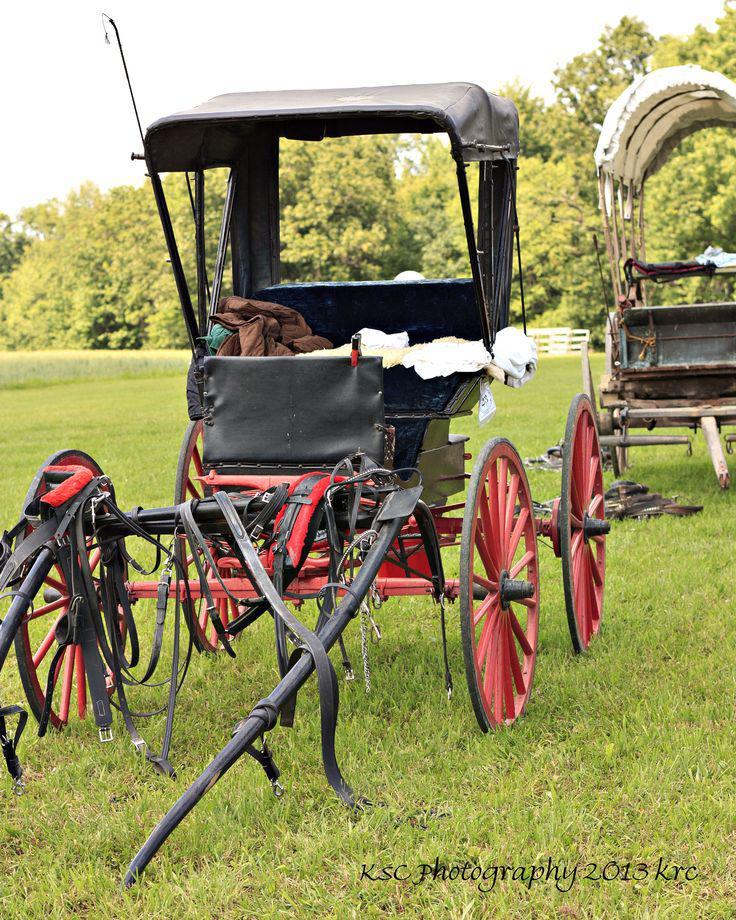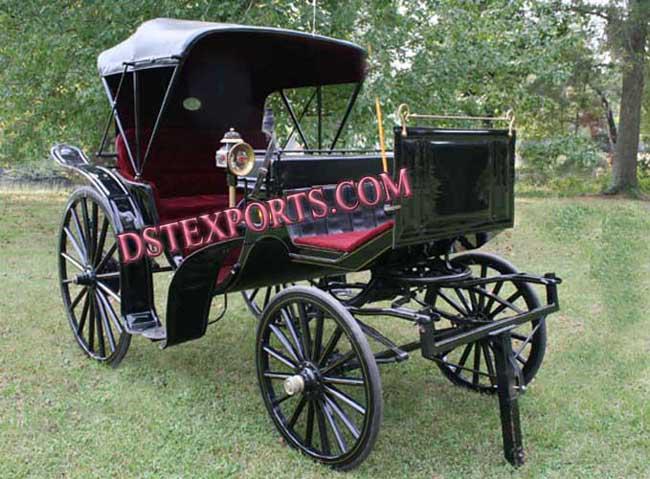The first image is the image on the left, the second image is the image on the right. Analyze the images presented: Is the assertion "At least one of the carriages has wheels with red spokes." valid? Answer yes or no. Yes. 